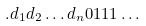<formula> <loc_0><loc_0><loc_500><loc_500>. d _ { 1 } d _ { 2 } \dots d _ { n } 0 1 1 1 \dots</formula> 